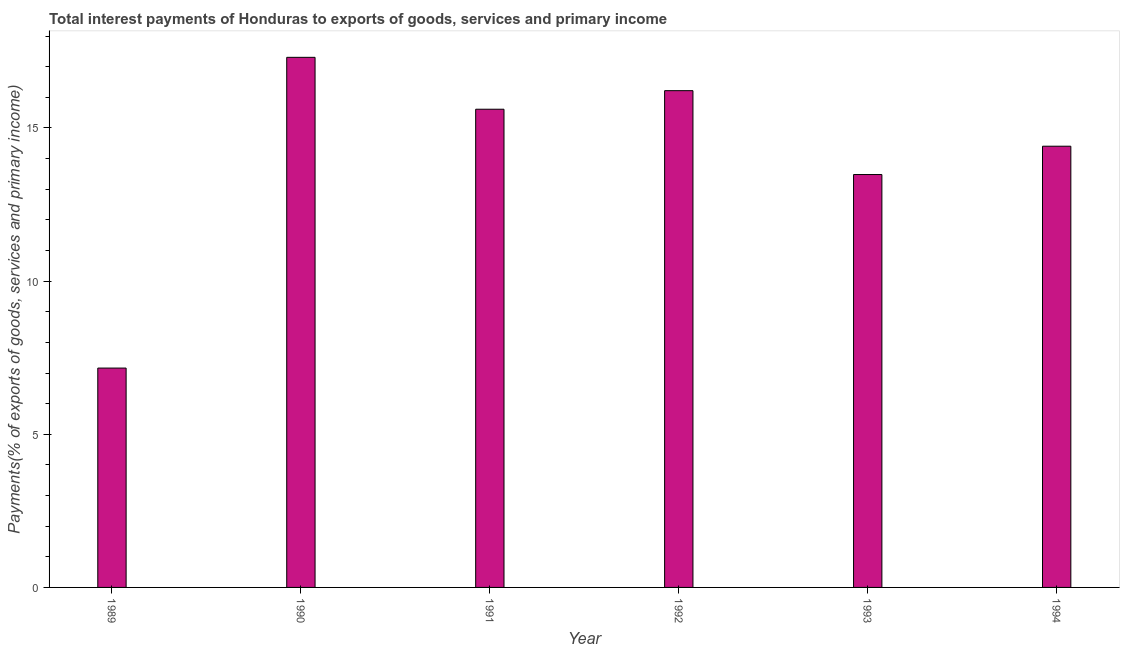What is the title of the graph?
Give a very brief answer. Total interest payments of Honduras to exports of goods, services and primary income. What is the label or title of the X-axis?
Ensure brevity in your answer.  Year. What is the label or title of the Y-axis?
Make the answer very short. Payments(% of exports of goods, services and primary income). What is the total interest payments on external debt in 1990?
Your response must be concise. 17.31. Across all years, what is the maximum total interest payments on external debt?
Your answer should be compact. 17.31. Across all years, what is the minimum total interest payments on external debt?
Make the answer very short. 7.16. In which year was the total interest payments on external debt minimum?
Make the answer very short. 1989. What is the sum of the total interest payments on external debt?
Provide a succinct answer. 84.18. What is the difference between the total interest payments on external debt in 1992 and 1993?
Make the answer very short. 2.74. What is the average total interest payments on external debt per year?
Give a very brief answer. 14.03. What is the median total interest payments on external debt?
Offer a very short reply. 15.01. In how many years, is the total interest payments on external debt greater than 4 %?
Your response must be concise. 6. What is the ratio of the total interest payments on external debt in 1990 to that in 1992?
Keep it short and to the point. 1.07. Is the difference between the total interest payments on external debt in 1989 and 1990 greater than the difference between any two years?
Your answer should be compact. Yes. What is the difference between the highest and the second highest total interest payments on external debt?
Ensure brevity in your answer.  1.09. What is the difference between the highest and the lowest total interest payments on external debt?
Provide a short and direct response. 10.14. How many bars are there?
Your answer should be compact. 6. Are the values on the major ticks of Y-axis written in scientific E-notation?
Your answer should be compact. No. What is the Payments(% of exports of goods, services and primary income) in 1989?
Ensure brevity in your answer.  7.16. What is the Payments(% of exports of goods, services and primary income) in 1990?
Ensure brevity in your answer.  17.31. What is the Payments(% of exports of goods, services and primary income) of 1991?
Provide a short and direct response. 15.61. What is the Payments(% of exports of goods, services and primary income) of 1992?
Offer a very short reply. 16.22. What is the Payments(% of exports of goods, services and primary income) of 1993?
Your answer should be very brief. 13.48. What is the Payments(% of exports of goods, services and primary income) of 1994?
Make the answer very short. 14.4. What is the difference between the Payments(% of exports of goods, services and primary income) in 1989 and 1990?
Provide a succinct answer. -10.14. What is the difference between the Payments(% of exports of goods, services and primary income) in 1989 and 1991?
Offer a terse response. -8.45. What is the difference between the Payments(% of exports of goods, services and primary income) in 1989 and 1992?
Your answer should be compact. -9.06. What is the difference between the Payments(% of exports of goods, services and primary income) in 1989 and 1993?
Your answer should be very brief. -6.32. What is the difference between the Payments(% of exports of goods, services and primary income) in 1989 and 1994?
Offer a very short reply. -7.24. What is the difference between the Payments(% of exports of goods, services and primary income) in 1990 and 1991?
Offer a terse response. 1.69. What is the difference between the Payments(% of exports of goods, services and primary income) in 1990 and 1992?
Provide a short and direct response. 1.09. What is the difference between the Payments(% of exports of goods, services and primary income) in 1990 and 1993?
Keep it short and to the point. 3.83. What is the difference between the Payments(% of exports of goods, services and primary income) in 1990 and 1994?
Make the answer very short. 2.9. What is the difference between the Payments(% of exports of goods, services and primary income) in 1991 and 1992?
Your answer should be compact. -0.61. What is the difference between the Payments(% of exports of goods, services and primary income) in 1991 and 1993?
Make the answer very short. 2.13. What is the difference between the Payments(% of exports of goods, services and primary income) in 1991 and 1994?
Offer a terse response. 1.21. What is the difference between the Payments(% of exports of goods, services and primary income) in 1992 and 1993?
Give a very brief answer. 2.74. What is the difference between the Payments(% of exports of goods, services and primary income) in 1992 and 1994?
Offer a terse response. 1.81. What is the difference between the Payments(% of exports of goods, services and primary income) in 1993 and 1994?
Your answer should be compact. -0.92. What is the ratio of the Payments(% of exports of goods, services and primary income) in 1989 to that in 1990?
Offer a terse response. 0.41. What is the ratio of the Payments(% of exports of goods, services and primary income) in 1989 to that in 1991?
Your response must be concise. 0.46. What is the ratio of the Payments(% of exports of goods, services and primary income) in 1989 to that in 1992?
Keep it short and to the point. 0.44. What is the ratio of the Payments(% of exports of goods, services and primary income) in 1989 to that in 1993?
Your response must be concise. 0.53. What is the ratio of the Payments(% of exports of goods, services and primary income) in 1989 to that in 1994?
Provide a short and direct response. 0.5. What is the ratio of the Payments(% of exports of goods, services and primary income) in 1990 to that in 1991?
Provide a short and direct response. 1.11. What is the ratio of the Payments(% of exports of goods, services and primary income) in 1990 to that in 1992?
Offer a very short reply. 1.07. What is the ratio of the Payments(% of exports of goods, services and primary income) in 1990 to that in 1993?
Your answer should be compact. 1.28. What is the ratio of the Payments(% of exports of goods, services and primary income) in 1990 to that in 1994?
Offer a terse response. 1.2. What is the ratio of the Payments(% of exports of goods, services and primary income) in 1991 to that in 1992?
Your answer should be very brief. 0.96. What is the ratio of the Payments(% of exports of goods, services and primary income) in 1991 to that in 1993?
Provide a short and direct response. 1.16. What is the ratio of the Payments(% of exports of goods, services and primary income) in 1991 to that in 1994?
Your response must be concise. 1.08. What is the ratio of the Payments(% of exports of goods, services and primary income) in 1992 to that in 1993?
Provide a succinct answer. 1.2. What is the ratio of the Payments(% of exports of goods, services and primary income) in 1992 to that in 1994?
Ensure brevity in your answer.  1.13. What is the ratio of the Payments(% of exports of goods, services and primary income) in 1993 to that in 1994?
Offer a very short reply. 0.94. 